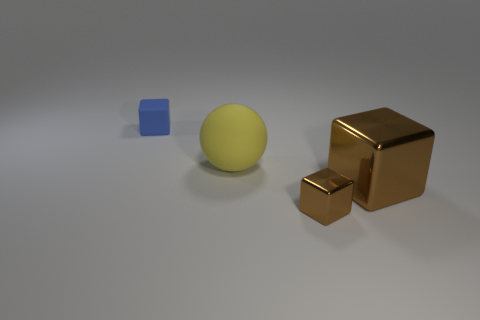What can you infer about the materials of the objects in the image? Based on their appearances, the blue cube seems to have a matte finish, which suggests that it might be made of a material like plastic. The yellow sphere shows a slight reflection and appears smooth, which can often be characteristics of a rubber material. The brown blocks have highly reflective surfaces, indicating that they are likely metallic, giving an impression of potentially being made of bronze or a similar material. 